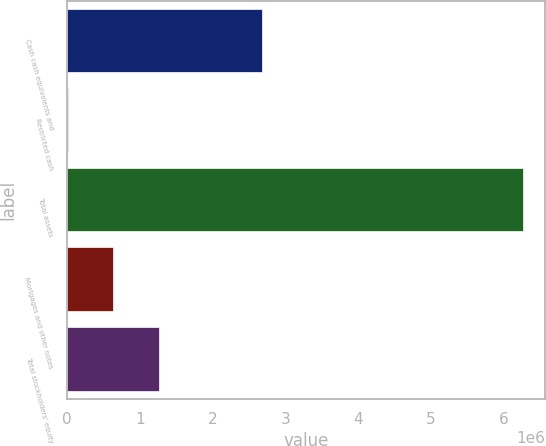Convert chart to OTSL. <chart><loc_0><loc_0><loc_500><loc_500><bar_chart><fcel>Cash cash equivalents and<fcel>Restricted cash<fcel>Total assets<fcel>Mortgages and other notes<fcel>Total stockholders' equity<nl><fcel>2.687e+06<fcel>9972<fcel>6.26058e+06<fcel>635033<fcel>1.26009e+06<nl></chart> 